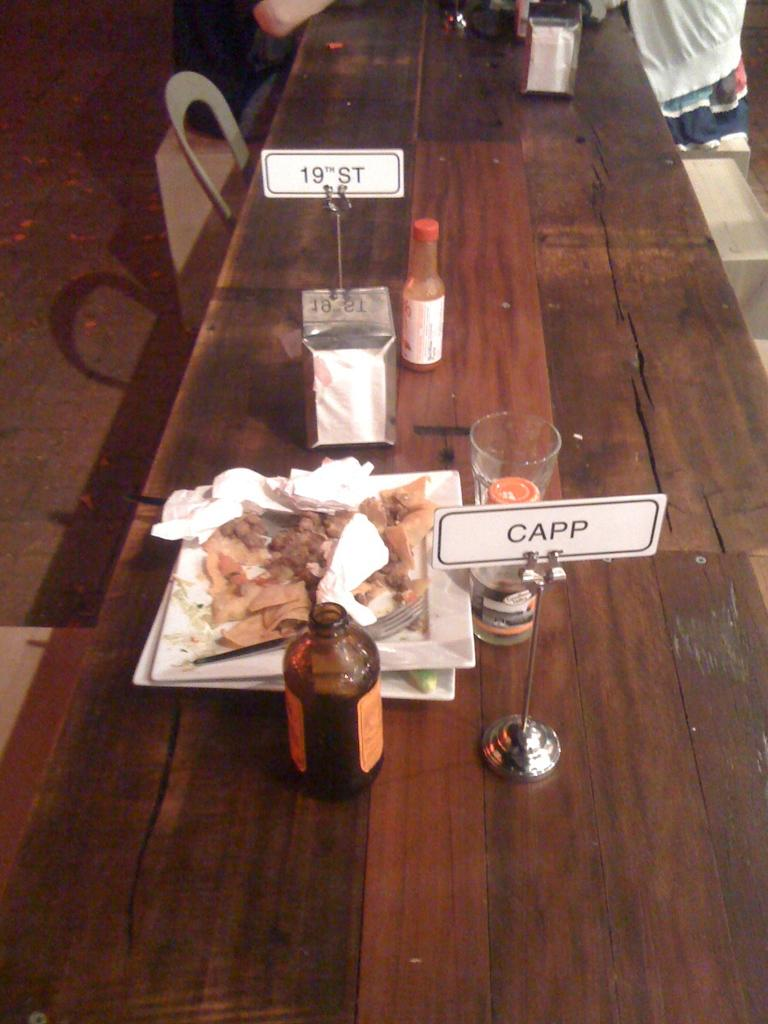<image>
Describe the image concisely. A long wooden table has a small sign that says CAPP on it. 